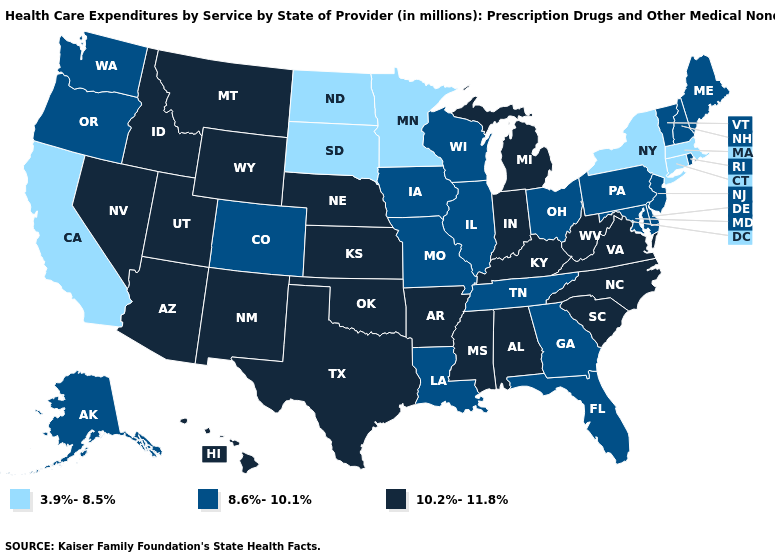What is the value of Arkansas?
Keep it brief. 10.2%-11.8%. What is the highest value in states that border Georgia?
Write a very short answer. 10.2%-11.8%. Does South Carolina have the lowest value in the USA?
Concise answer only. No. Does Missouri have the lowest value in the MidWest?
Give a very brief answer. No. What is the highest value in states that border Arizona?
Give a very brief answer. 10.2%-11.8%. Which states hav the highest value in the MidWest?
Concise answer only. Indiana, Kansas, Michigan, Nebraska. What is the lowest value in the West?
Keep it brief. 3.9%-8.5%. What is the highest value in states that border South Dakota?
Concise answer only. 10.2%-11.8%. What is the value of Washington?
Quick response, please. 8.6%-10.1%. Does the first symbol in the legend represent the smallest category?
Short answer required. Yes. What is the highest value in the South ?
Be succinct. 10.2%-11.8%. What is the lowest value in states that border New York?
Concise answer only. 3.9%-8.5%. Name the states that have a value in the range 3.9%-8.5%?
Keep it brief. California, Connecticut, Massachusetts, Minnesota, New York, North Dakota, South Dakota. Which states have the highest value in the USA?
Short answer required. Alabama, Arizona, Arkansas, Hawaii, Idaho, Indiana, Kansas, Kentucky, Michigan, Mississippi, Montana, Nebraska, Nevada, New Mexico, North Carolina, Oklahoma, South Carolina, Texas, Utah, Virginia, West Virginia, Wyoming. What is the highest value in states that border Missouri?
Concise answer only. 10.2%-11.8%. 